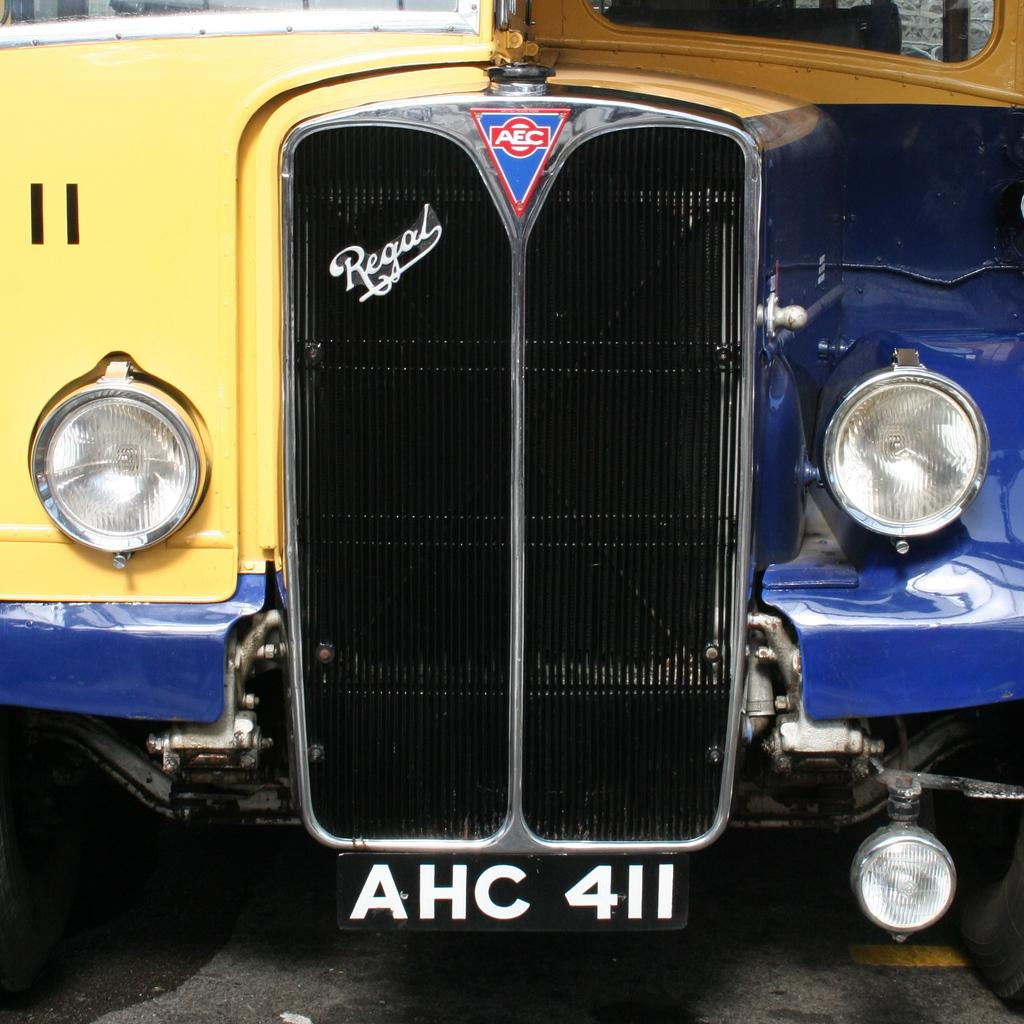What is the main subject of the image? The main subject of the image is a vehicle. What colors can be seen on the vehicle? The vehicle has yellow, blue, and black colors. Is there any identifying information visible on the vehicle? Yes, there is a number plate visible on the vehicle. Can you see a river flowing near the vehicle in the image? No, there is no river visible in the image. Is the vehicle being used for skating in the image? No, the vehicle is not being used for skating; it is a stationary subject in the image. 